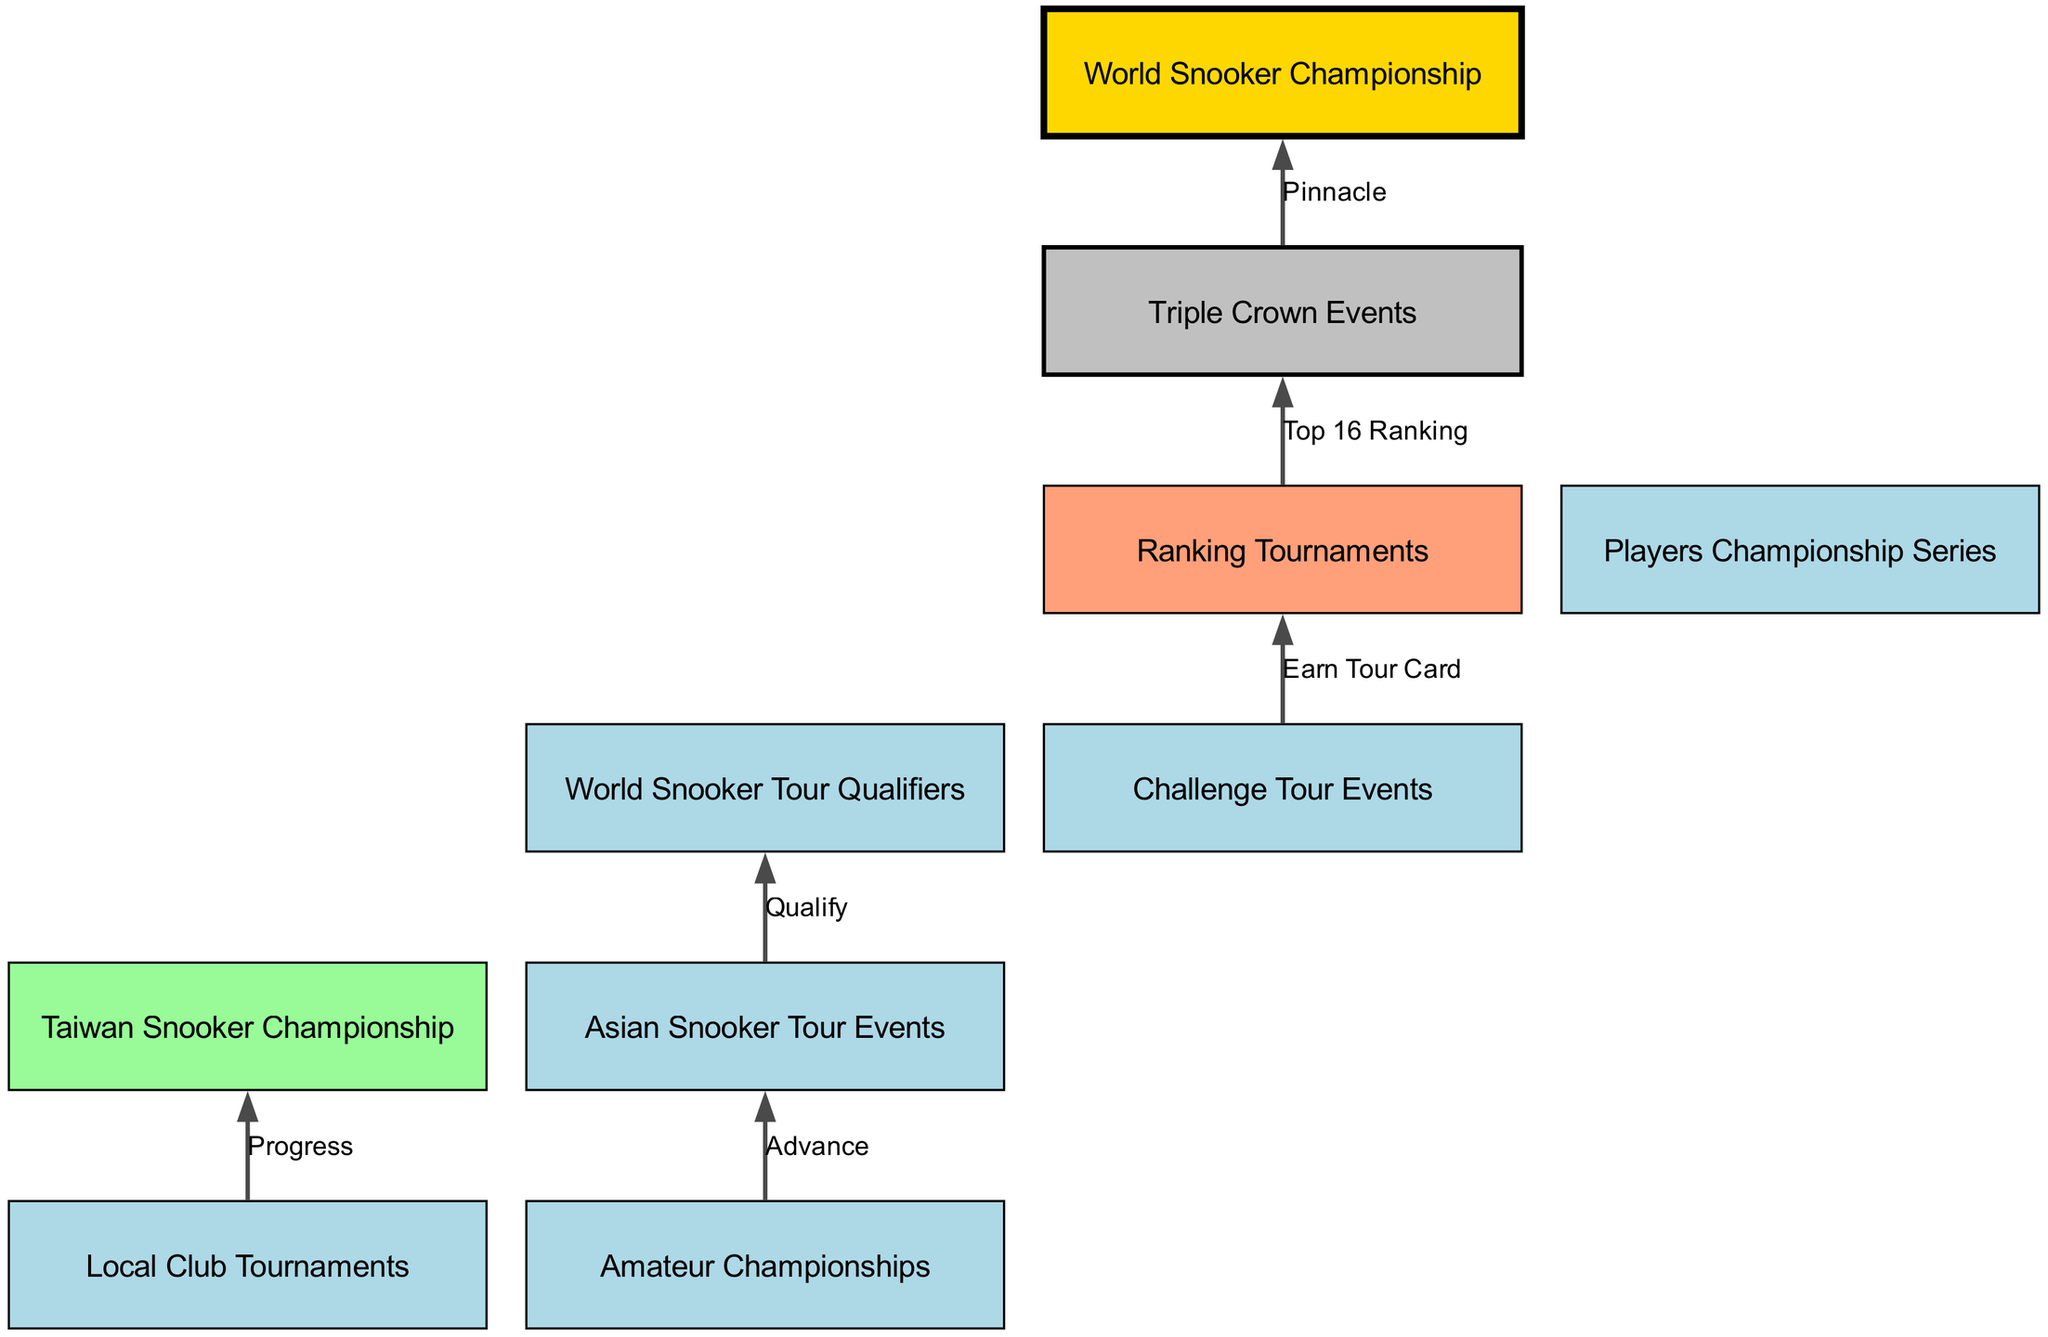What are the two types of tournaments at the first level? The diagram states that the first level includes "Local Club Tournaments" and "Amateur Championships." These are the only two nodes at this level.
Answer: Local Club Tournaments, Amateur Championships How many levels are there in the tournament hierarchy? By counting the levels from 1 to 6 in the diagram, we see there are six distinct levels.
Answer: 6 Which tournament is directly connected to "Ranking Tournaments"? "Triple Crown Events" is the tournament that is connected to "Ranking Tournaments" according to the connections in the diagram.
Answer: Triple Crown Events What is the final tournament connected to "Triple Crown Events"? From the diagram, it's clear that "Triple Crown Events" leads directly to the "World Snooker Championship," which is the final tournament in the hierarchy.
Answer: World Snooker Championship What is the relationship between "Challenge Tour Events" and "Ranking Tournaments"? The diagram denotes that "Challenge Tour Events" leads to "Ranking Tournaments" with the label "Earn Tour Card," showing a progression from challenge events to ranking tournaments.
Answer: Earn Tour Card What is the first major tournament in the hierarchy after local competitions? The first major tournament after local competitions is the "Taiwan Snooker Championship," which is the target of progression from "Local Club Tournaments."
Answer: Taiwan Snooker Championship Which tournaments represent the pinnacle of the snooker tournament hierarchy? "World Snooker Championship" is denoted as the pinnacle of the hierarchy, as it is the ultimate destination after the "Triple Crown Events."
Answer: World Snooker Championship How does one qualify for the "World Snooker Tour Qualifiers"? According to the diagram, a player qualifies for the "World Snooker Tour Qualifiers" by advancing through the "Asian Snooker Tour Events," indicating a pathway of progression.
Answer: Advance 